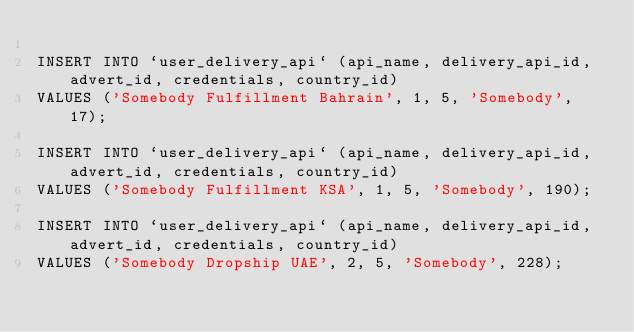<code> <loc_0><loc_0><loc_500><loc_500><_SQL_>
INSERT INTO `user_delivery_api` (api_name, delivery_api_id, advert_id, credentials, country_id)
VALUES ('Somebody Fulfillment Bahrain', 1, 5, 'Somebody', 17);

INSERT INTO `user_delivery_api` (api_name, delivery_api_id, advert_id, credentials, country_id)
VALUES ('Somebody Fulfillment KSA', 1, 5, 'Somebody', 190);

INSERT INTO `user_delivery_api` (api_name, delivery_api_id, advert_id, credentials, country_id)
VALUES ('Somebody Dropship UAE', 2, 5, 'Somebody', 228);</code> 